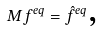Convert formula to latex. <formula><loc_0><loc_0><loc_500><loc_500>M f ^ { e q } = \hat { f } ^ { e q } \text {,}</formula> 